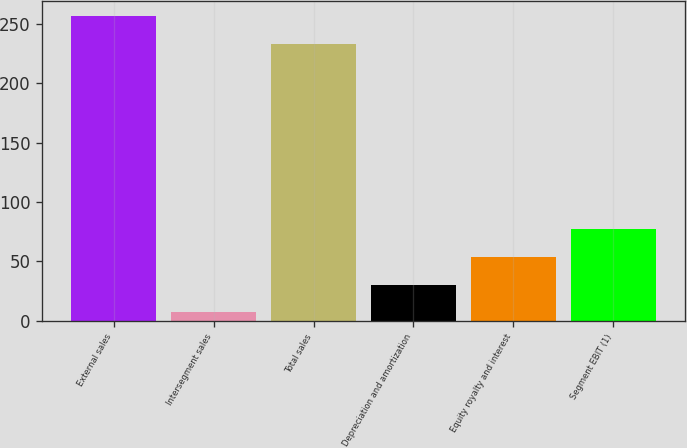Convert chart. <chart><loc_0><loc_0><loc_500><loc_500><bar_chart><fcel>External sales<fcel>Intersegment sales<fcel>Total sales<fcel>Depreciation and amortization<fcel>Equity royalty and interest<fcel>Segment EBIT (1)<nl><fcel>256.3<fcel>7<fcel>233<fcel>30.3<fcel>53.6<fcel>76.9<nl></chart> 